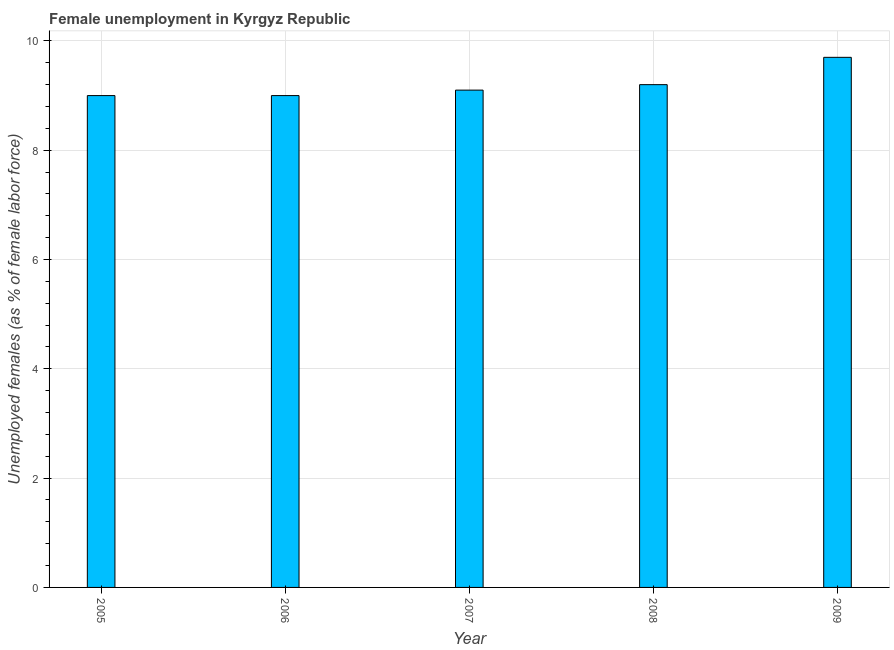What is the title of the graph?
Keep it short and to the point. Female unemployment in Kyrgyz Republic. What is the label or title of the X-axis?
Ensure brevity in your answer.  Year. What is the label or title of the Y-axis?
Offer a very short reply. Unemployed females (as % of female labor force). What is the unemployed females population in 2009?
Make the answer very short. 9.7. Across all years, what is the maximum unemployed females population?
Offer a terse response. 9.7. In which year was the unemployed females population maximum?
Your answer should be very brief. 2009. What is the sum of the unemployed females population?
Your answer should be very brief. 46. What is the difference between the unemployed females population in 2005 and 2007?
Your answer should be compact. -0.1. What is the median unemployed females population?
Keep it short and to the point. 9.1. Do a majority of the years between 2007 and 2005 (inclusive) have unemployed females population greater than 8 %?
Your response must be concise. Yes. What is the ratio of the unemployed females population in 2006 to that in 2008?
Keep it short and to the point. 0.98. Is the unemployed females population in 2007 less than that in 2008?
Offer a terse response. Yes. Is the difference between the unemployed females population in 2006 and 2007 greater than the difference between any two years?
Your response must be concise. No. In how many years, is the unemployed females population greater than the average unemployed females population taken over all years?
Make the answer very short. 1. How many bars are there?
Your answer should be compact. 5. Are all the bars in the graph horizontal?
Ensure brevity in your answer.  No. How many years are there in the graph?
Offer a very short reply. 5. What is the Unemployed females (as % of female labor force) in 2005?
Provide a succinct answer. 9. What is the Unemployed females (as % of female labor force) of 2007?
Provide a succinct answer. 9.1. What is the Unemployed females (as % of female labor force) in 2008?
Keep it short and to the point. 9.2. What is the Unemployed females (as % of female labor force) in 2009?
Your response must be concise. 9.7. What is the difference between the Unemployed females (as % of female labor force) in 2005 and 2006?
Offer a very short reply. 0. What is the difference between the Unemployed females (as % of female labor force) in 2005 and 2008?
Provide a succinct answer. -0.2. What is the difference between the Unemployed females (as % of female labor force) in 2005 and 2009?
Provide a succinct answer. -0.7. What is the difference between the Unemployed females (as % of female labor force) in 2007 and 2008?
Offer a terse response. -0.1. What is the difference between the Unemployed females (as % of female labor force) in 2007 and 2009?
Provide a succinct answer. -0.6. What is the difference between the Unemployed females (as % of female labor force) in 2008 and 2009?
Ensure brevity in your answer.  -0.5. What is the ratio of the Unemployed females (as % of female labor force) in 2005 to that in 2008?
Provide a short and direct response. 0.98. What is the ratio of the Unemployed females (as % of female labor force) in 2005 to that in 2009?
Your response must be concise. 0.93. What is the ratio of the Unemployed females (as % of female labor force) in 2006 to that in 2009?
Offer a terse response. 0.93. What is the ratio of the Unemployed females (as % of female labor force) in 2007 to that in 2008?
Your response must be concise. 0.99. What is the ratio of the Unemployed females (as % of female labor force) in 2007 to that in 2009?
Your answer should be very brief. 0.94. What is the ratio of the Unemployed females (as % of female labor force) in 2008 to that in 2009?
Offer a terse response. 0.95. 